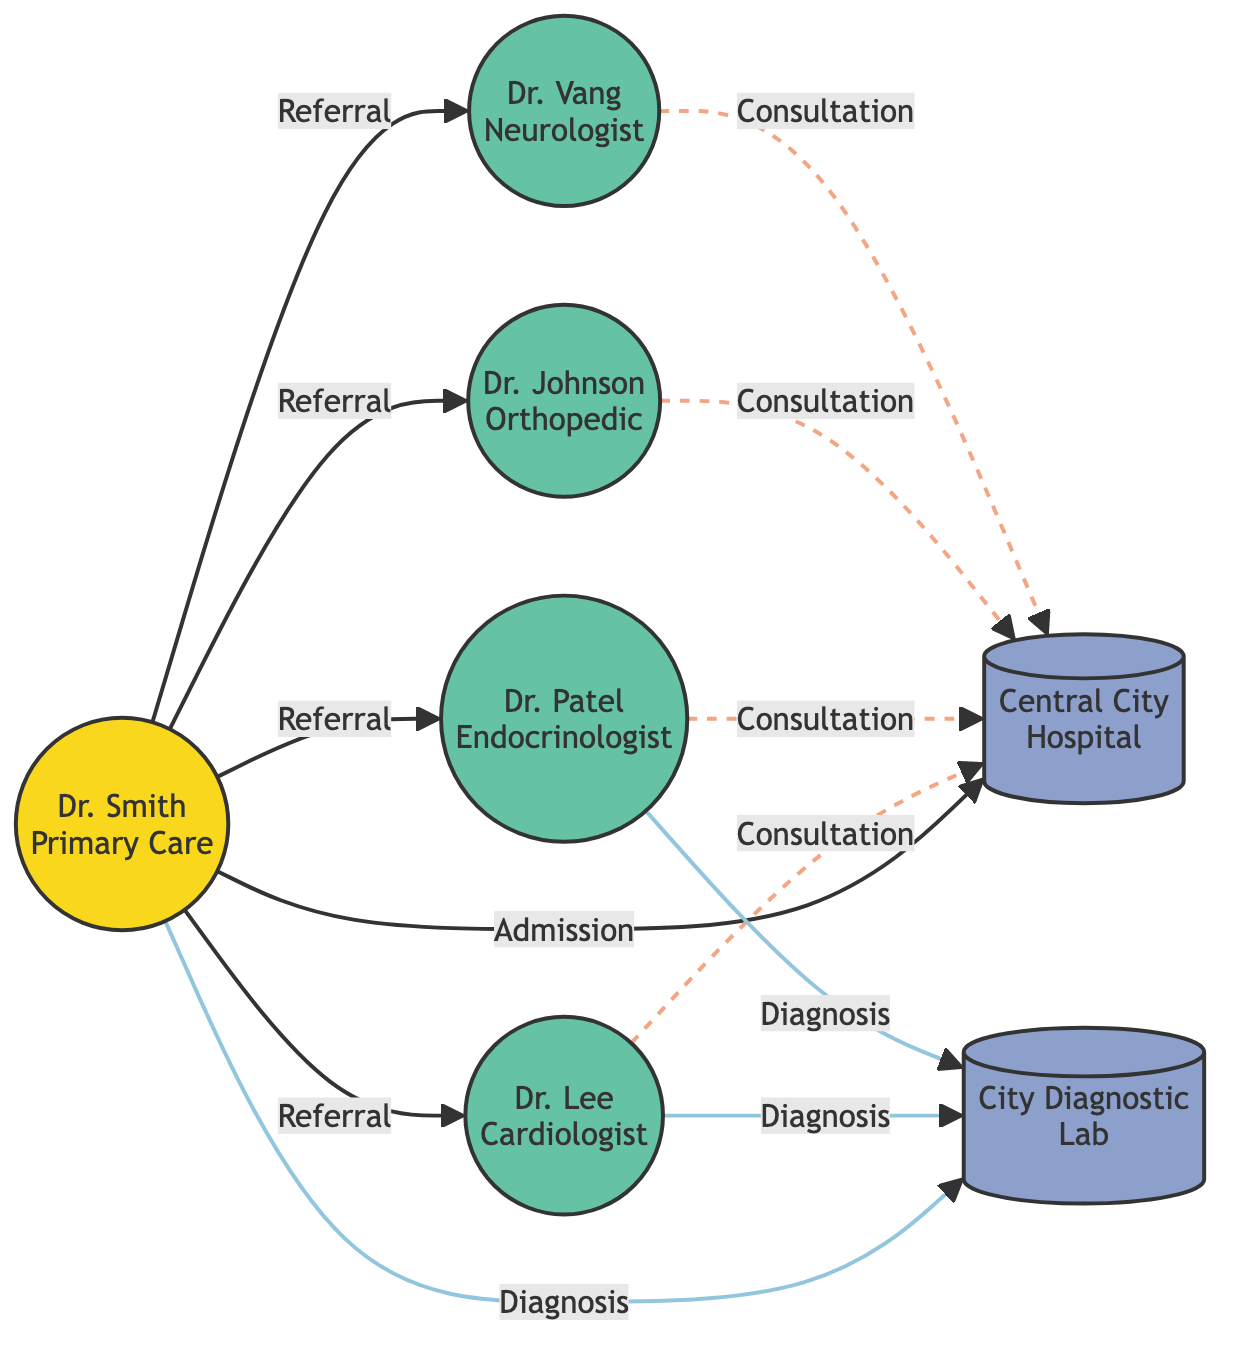What type of node is Dr. Smith? Dr. Smith is identified as the "Primary Care Provider" in the nodes list, which is categorized under the type "Primary."
Answer: Primary How many specialists are in the diagram? The nodes list shows four specialists: Dr. Lee, Dr. Patel, Dr. Johnson, and Dr. Vang. Therefore, counting these gives a total of four specialists.
Answer: 4 What is the referral reason from Dr. Smith to Dr. Lee? The link from Dr. Smith to Dr. Lee states, "Referred for heart condition evaluation," which provides the specific reason for the referral.
Answer: Referred for heart condition evaluation Which facility is Dr. Vang directly connected to for consultation? Dr. Vang is linked to the Central City Hospital (node 6) through a consultation described as "Consultation for neurological monitoring."
Answer: Central City Hospital How many total nodes are in the diagram? The nodes list consists of seven entries (1 to 7), indicating that there are a total of seven nodes in the diagram.
Answer: 7 Which specialist provides consultation at the hospital? All four specialists (Dr. Lee, Dr. Patel, Dr. Johnson, Dr. Vang) have links to the hospital for consultation. Therefore, the answer encompasses all these specialists.
Answer: Dr. Lee, Dr. Patel, Dr. Johnson, Dr. Vang What is the diagnosis type from Dr. Smith to the City Diagnostic Lab? The link from Dr. Smith to the City Diagnostic Lab states, "Diagnosis" indicating the type of interaction is a diagnostic test referral.
Answer: Diagnosis Which primary care provider is referenced in this network? The only primary care provider in this network is Dr. Smith as indicated in the nodes list.
Answer: Dr. Smith What type of relationship exists between Dr. Patel and Central City Hospital? The relationship is defined as a "consultation," which indicates a professional interaction between Dr. Patel and the hospital for patient care.
Answer: consultation 